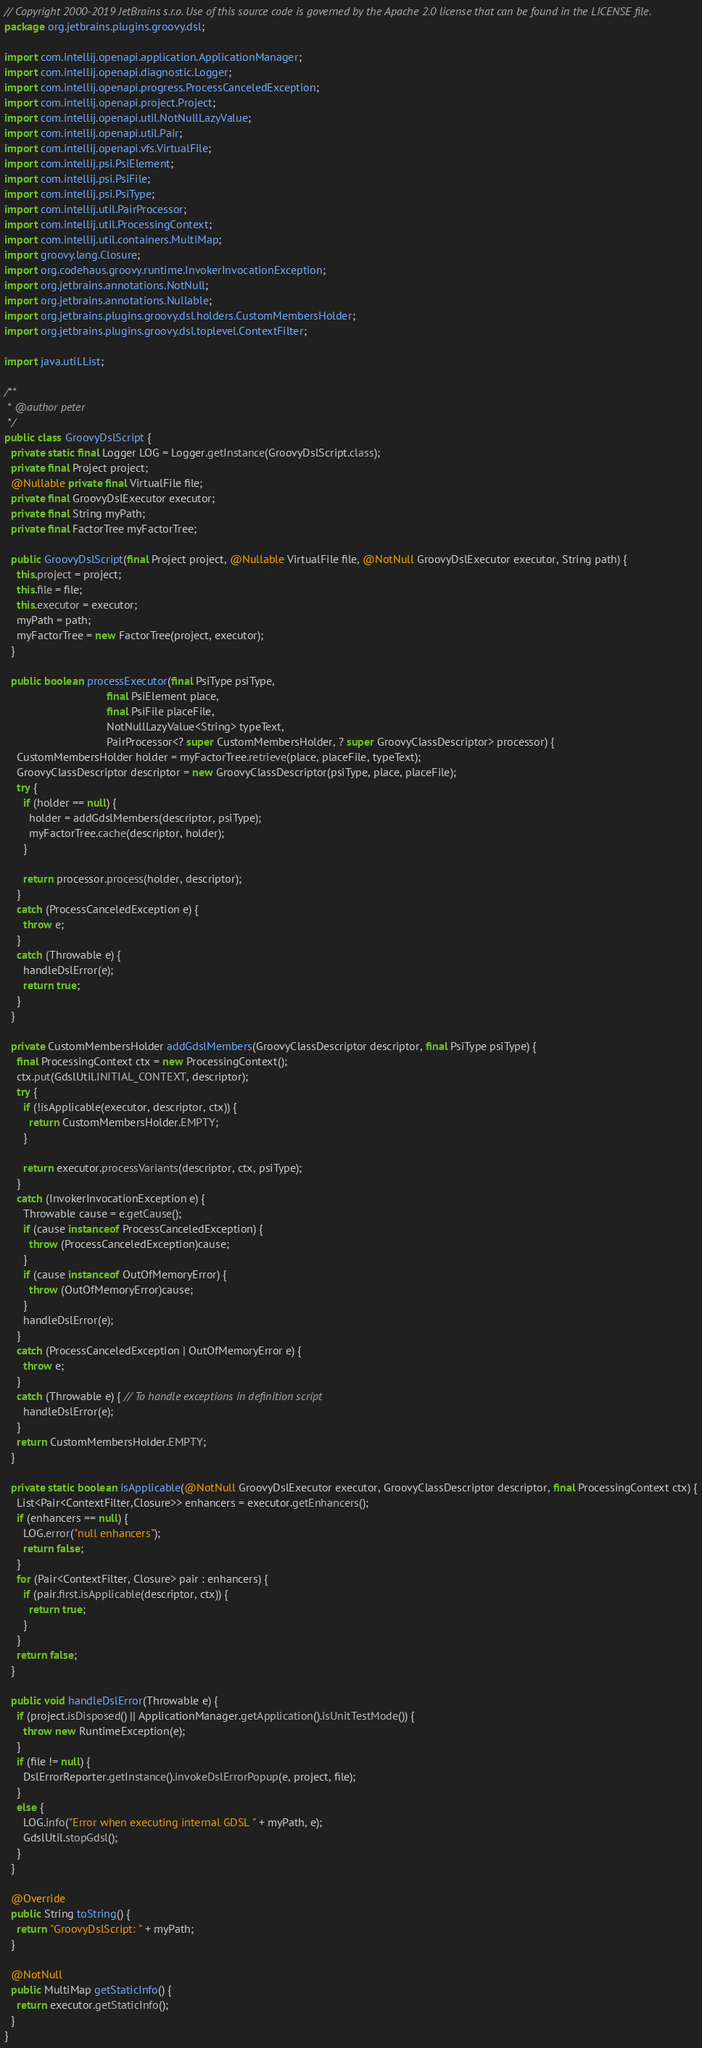<code> <loc_0><loc_0><loc_500><loc_500><_Java_>// Copyright 2000-2019 JetBrains s.r.o. Use of this source code is governed by the Apache 2.0 license that can be found in the LICENSE file.
package org.jetbrains.plugins.groovy.dsl;

import com.intellij.openapi.application.ApplicationManager;
import com.intellij.openapi.diagnostic.Logger;
import com.intellij.openapi.progress.ProcessCanceledException;
import com.intellij.openapi.project.Project;
import com.intellij.openapi.util.NotNullLazyValue;
import com.intellij.openapi.util.Pair;
import com.intellij.openapi.vfs.VirtualFile;
import com.intellij.psi.PsiElement;
import com.intellij.psi.PsiFile;
import com.intellij.psi.PsiType;
import com.intellij.util.PairProcessor;
import com.intellij.util.ProcessingContext;
import com.intellij.util.containers.MultiMap;
import groovy.lang.Closure;
import org.codehaus.groovy.runtime.InvokerInvocationException;
import org.jetbrains.annotations.NotNull;
import org.jetbrains.annotations.Nullable;
import org.jetbrains.plugins.groovy.dsl.holders.CustomMembersHolder;
import org.jetbrains.plugins.groovy.dsl.toplevel.ContextFilter;

import java.util.List;

/**
 * @author peter
 */
public class GroovyDslScript {
  private static final Logger LOG = Logger.getInstance(GroovyDslScript.class);
  private final Project project;
  @Nullable private final VirtualFile file;
  private final GroovyDslExecutor executor;
  private final String myPath;
  private final FactorTree myFactorTree;

  public GroovyDslScript(final Project project, @Nullable VirtualFile file, @NotNull GroovyDslExecutor executor, String path) {
    this.project = project;
    this.file = file;
    this.executor = executor;
    myPath = path;
    myFactorTree = new FactorTree(project, executor);
  }

  public boolean processExecutor(final PsiType psiType,
                                 final PsiElement place,
                                 final PsiFile placeFile,
                                 NotNullLazyValue<String> typeText,
                                 PairProcessor<? super CustomMembersHolder, ? super GroovyClassDescriptor> processor) {
    CustomMembersHolder holder = myFactorTree.retrieve(place, placeFile, typeText);
    GroovyClassDescriptor descriptor = new GroovyClassDescriptor(psiType, place, placeFile);
    try {
      if (holder == null) {
        holder = addGdslMembers(descriptor, psiType);
        myFactorTree.cache(descriptor, holder);
      }

      return processor.process(holder, descriptor);
    }
    catch (ProcessCanceledException e) {
      throw e;
    }
    catch (Throwable e) {
      handleDslError(e);
      return true;
    }
  }

  private CustomMembersHolder addGdslMembers(GroovyClassDescriptor descriptor, final PsiType psiType) {
    final ProcessingContext ctx = new ProcessingContext();
    ctx.put(GdslUtil.INITIAL_CONTEXT, descriptor);
    try {
      if (!isApplicable(executor, descriptor, ctx)) {
        return CustomMembersHolder.EMPTY;
      }

      return executor.processVariants(descriptor, ctx, psiType);
    }
    catch (InvokerInvocationException e) {
      Throwable cause = e.getCause();
      if (cause instanceof ProcessCanceledException) {
        throw (ProcessCanceledException)cause;
      }
      if (cause instanceof OutOfMemoryError) {
        throw (OutOfMemoryError)cause;
      }
      handleDslError(e);
    }
    catch (ProcessCanceledException | OutOfMemoryError e) {
      throw e;
    }
    catch (Throwable e) { // To handle exceptions in definition script
      handleDslError(e);
    }
    return CustomMembersHolder.EMPTY;
  }

  private static boolean isApplicable(@NotNull GroovyDslExecutor executor, GroovyClassDescriptor descriptor, final ProcessingContext ctx) {
    List<Pair<ContextFilter,Closure>> enhancers = executor.getEnhancers();
    if (enhancers == null) {
      LOG.error("null enhancers");
      return false;
    }
    for (Pair<ContextFilter, Closure> pair : enhancers) {
      if (pair.first.isApplicable(descriptor, ctx)) {
        return true;
      }
    }
    return false;
  }

  public void handleDslError(Throwable e) {
    if (project.isDisposed() || ApplicationManager.getApplication().isUnitTestMode()) {
      throw new RuntimeException(e);
    }
    if (file != null) {
      DslErrorReporter.getInstance().invokeDslErrorPopup(e, project, file);
    }
    else {
      LOG.info("Error when executing internal GDSL " + myPath, e);
      GdslUtil.stopGdsl();
    }
  }

  @Override
  public String toString() {
    return "GroovyDslScript: " + myPath;
  }

  @NotNull
  public MultiMap getStaticInfo() {
    return executor.getStaticInfo();
  }
}
</code> 